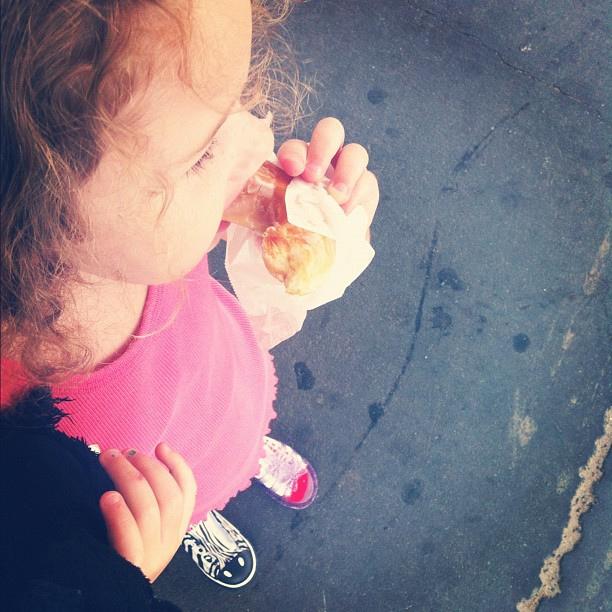What gender is this child?
Give a very brief answer. Female. What does the child have in her mouth?
Quick response, please. Food. Are the shoes supposed to be different colors?
Write a very short answer. No. 